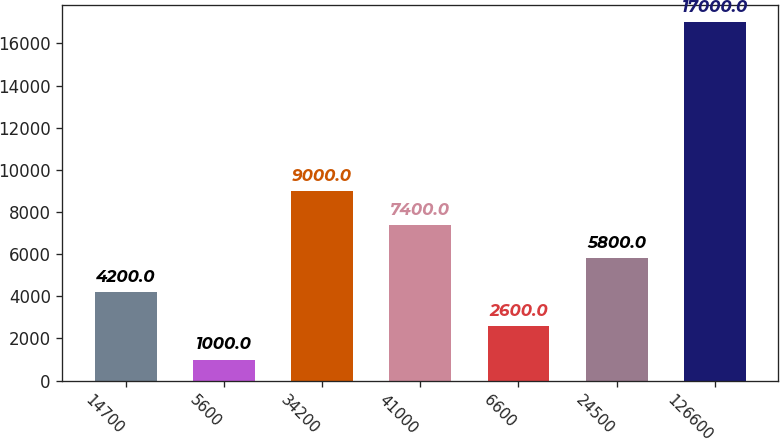<chart> <loc_0><loc_0><loc_500><loc_500><bar_chart><fcel>14700<fcel>5600<fcel>34200<fcel>41000<fcel>6600<fcel>24500<fcel>126600<nl><fcel>4200<fcel>1000<fcel>9000<fcel>7400<fcel>2600<fcel>5800<fcel>17000<nl></chart> 